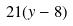Convert formula to latex. <formula><loc_0><loc_0><loc_500><loc_500>2 1 ( y - 8 )</formula> 